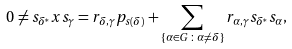<formula> <loc_0><loc_0><loc_500><loc_500>0 \neq s _ { \delta ^ { * } } x s _ { \gamma } = r _ { \delta , \gamma } p _ { s ( \delta ) } + \sum _ { \{ \alpha \in G \, \colon \, \alpha \neq \delta \} } r _ { \alpha , \gamma } s _ { \delta ^ { * } } s _ { \alpha } ,</formula> 